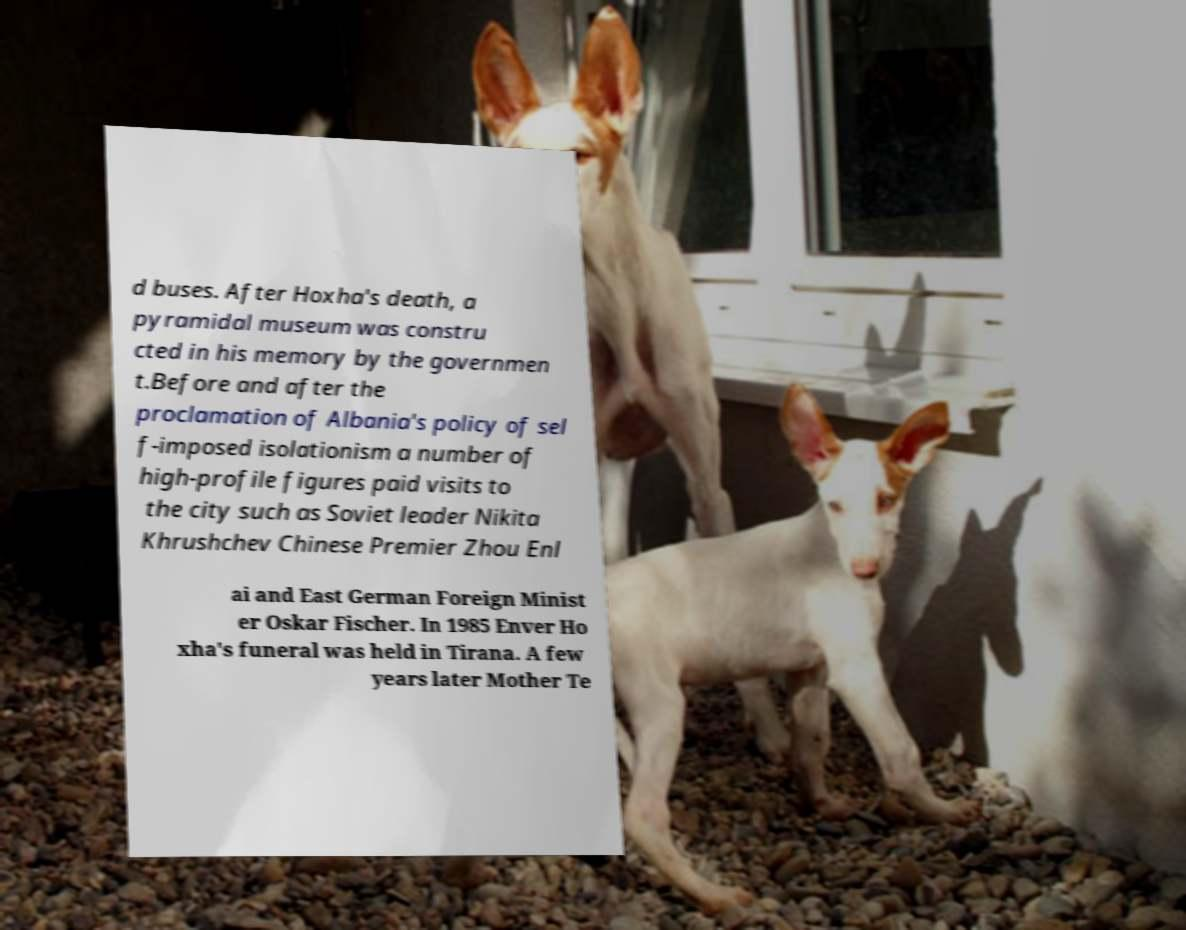What messages or text are displayed in this image? I need them in a readable, typed format. d buses. After Hoxha's death, a pyramidal museum was constru cted in his memory by the governmen t.Before and after the proclamation of Albania's policy of sel f-imposed isolationism a number of high-profile figures paid visits to the city such as Soviet leader Nikita Khrushchev Chinese Premier Zhou Enl ai and East German Foreign Minist er Oskar Fischer. In 1985 Enver Ho xha's funeral was held in Tirana. A few years later Mother Te 